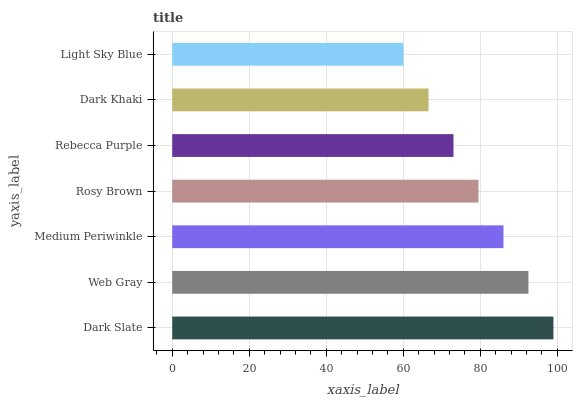Is Light Sky Blue the minimum?
Answer yes or no. Yes. Is Dark Slate the maximum?
Answer yes or no. Yes. Is Web Gray the minimum?
Answer yes or no. No. Is Web Gray the maximum?
Answer yes or no. No. Is Dark Slate greater than Web Gray?
Answer yes or no. Yes. Is Web Gray less than Dark Slate?
Answer yes or no. Yes. Is Web Gray greater than Dark Slate?
Answer yes or no. No. Is Dark Slate less than Web Gray?
Answer yes or no. No. Is Rosy Brown the high median?
Answer yes or no. Yes. Is Rosy Brown the low median?
Answer yes or no. Yes. Is Dark Slate the high median?
Answer yes or no. No. Is Web Gray the low median?
Answer yes or no. No. 